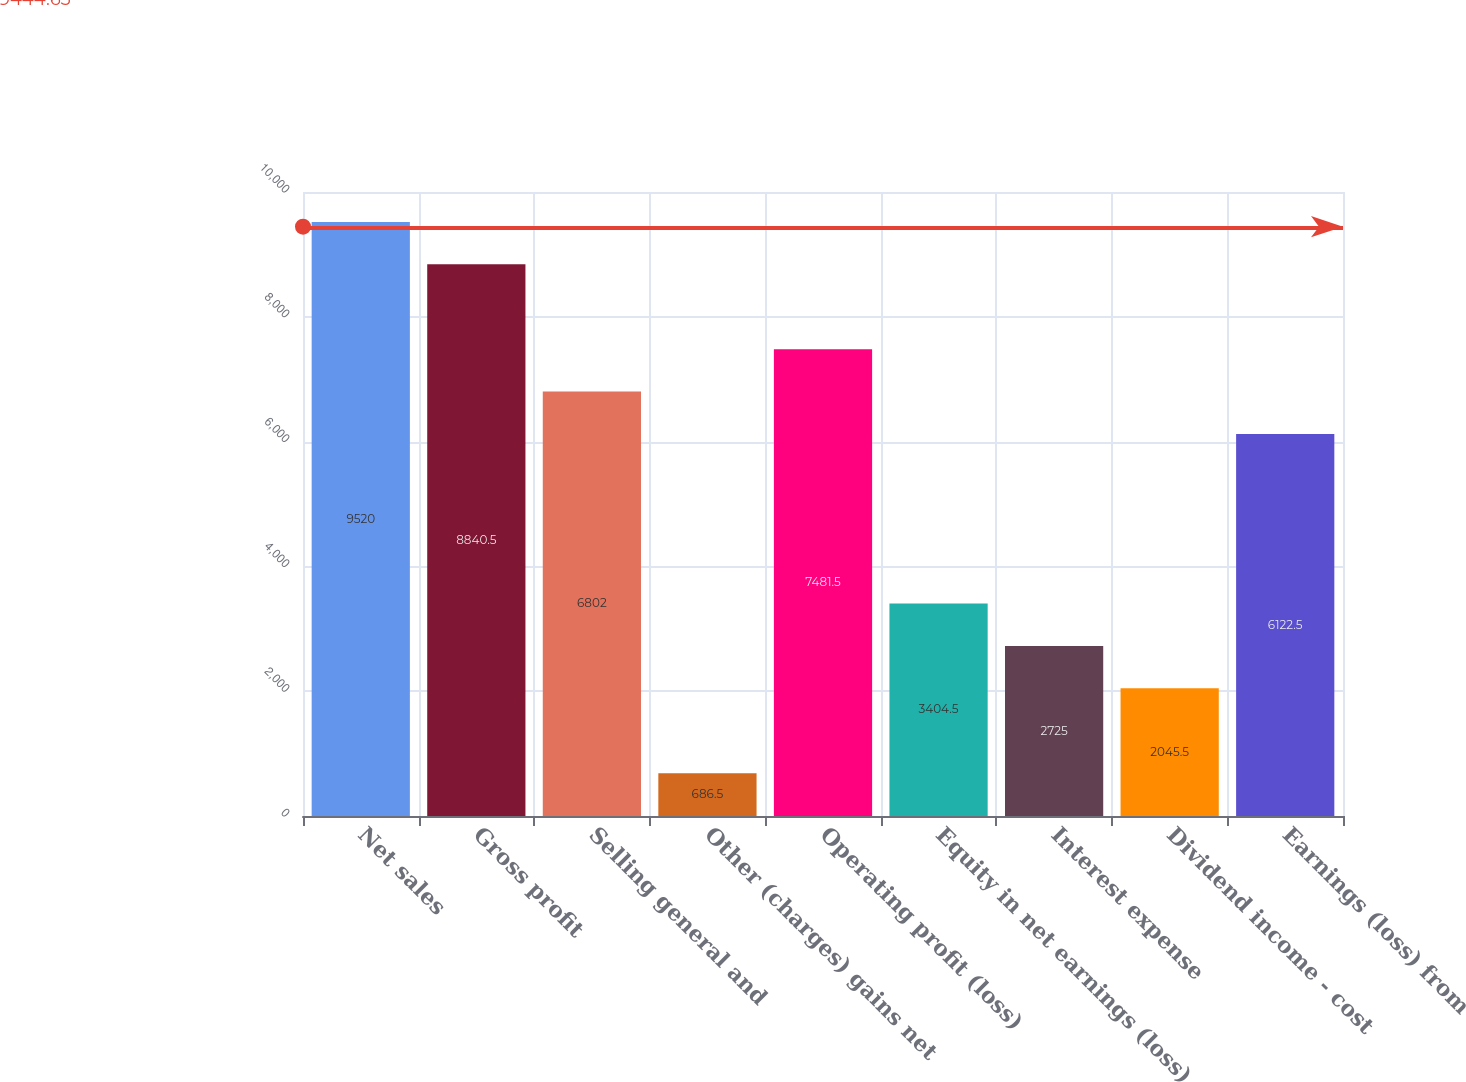Convert chart to OTSL. <chart><loc_0><loc_0><loc_500><loc_500><bar_chart><fcel>Net sales<fcel>Gross profit<fcel>Selling general and<fcel>Other (charges) gains net<fcel>Operating profit (loss)<fcel>Equity in net earnings (loss)<fcel>Interest expense<fcel>Dividend income - cost<fcel>Earnings (loss) from<nl><fcel>9520<fcel>8840.5<fcel>6802<fcel>686.5<fcel>7481.5<fcel>3404.5<fcel>2725<fcel>2045.5<fcel>6122.5<nl></chart> 